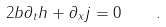<formula> <loc_0><loc_0><loc_500><loc_500>2 b \partial _ { t } h + \partial _ { x } j = 0 \quad .</formula> 